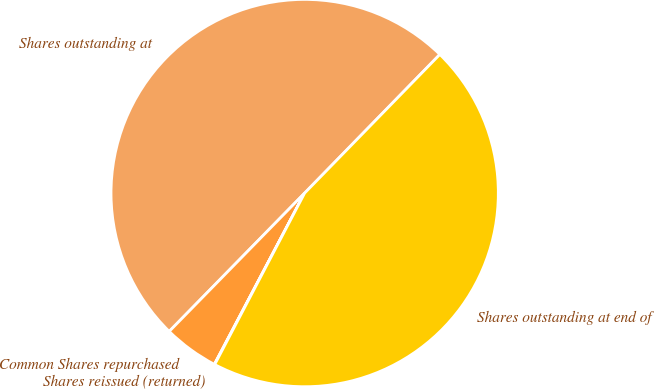Convert chart. <chart><loc_0><loc_0><loc_500><loc_500><pie_chart><fcel>Shares outstanding at<fcel>Common Shares repurchased<fcel>Shares reissued (returned)<fcel>Shares outstanding at end of<nl><fcel>49.97%<fcel>4.61%<fcel>0.03%<fcel>45.39%<nl></chart> 